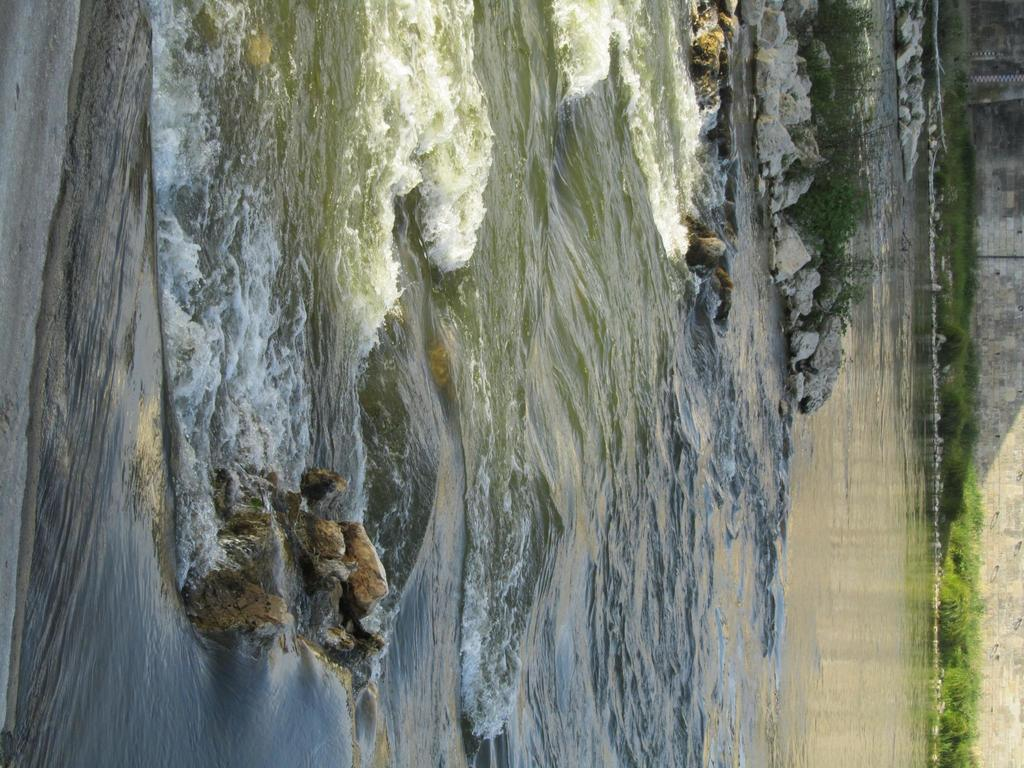What type of natural feature is present in the image? There is a lake in the image. What can be seen in the middle of the lake? There are stones in the middle of the lake. What is visible in the background of the image? There is a wall in the background of the image. What type of vegetation is present in front of the wall? There are plants in front of the wall. What type of insect can be seen crawling on the scale in the image? There is no insect or scale present in the image. How does the sleet affect the plants in the image? There is no sleet present in the image, so its effect on the plants cannot be determined. 